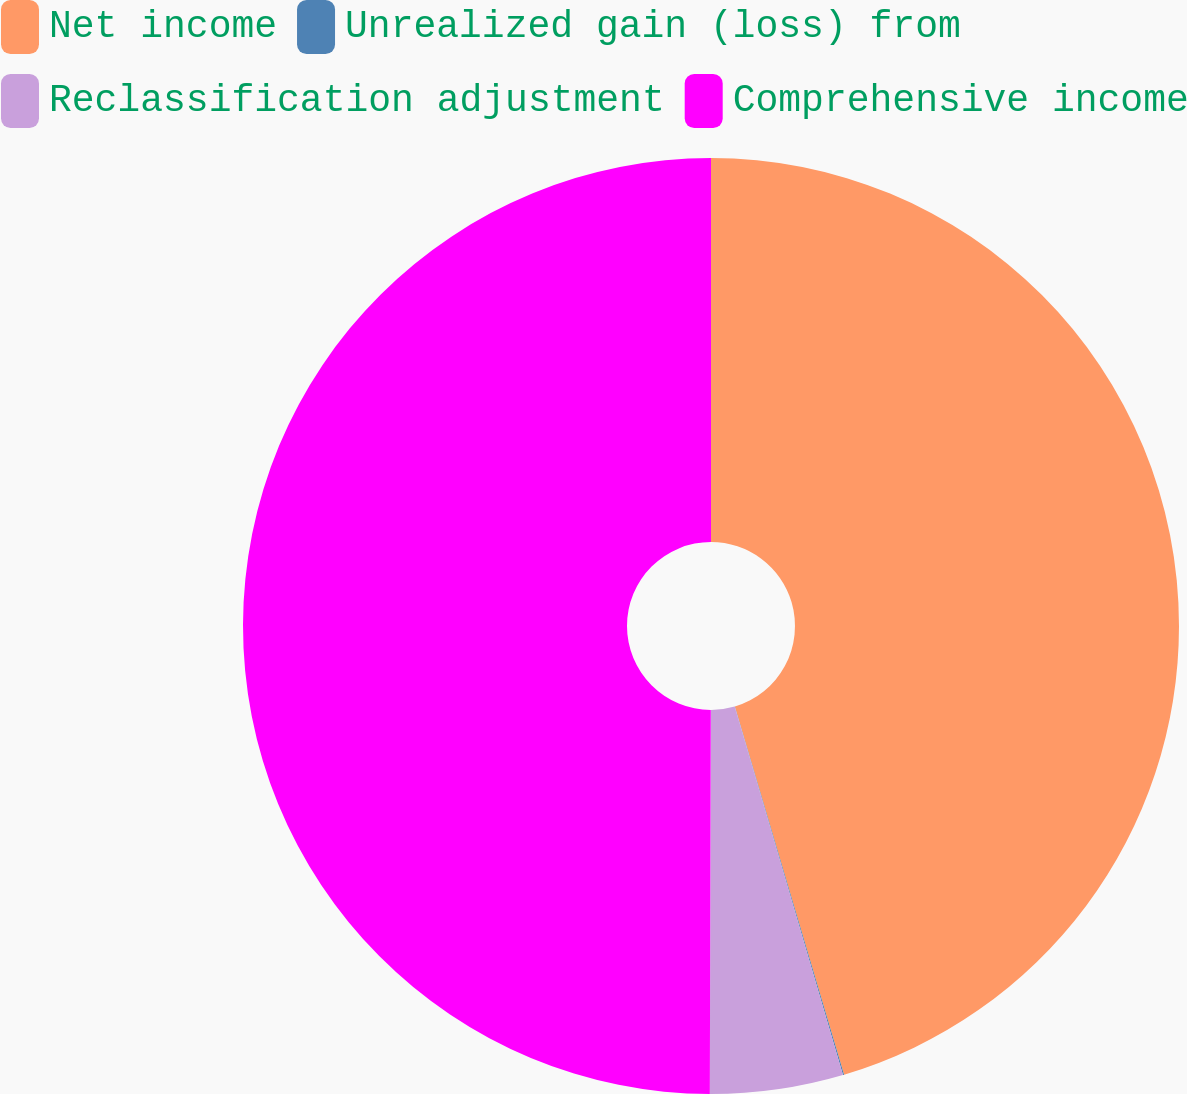Convert chart. <chart><loc_0><loc_0><loc_500><loc_500><pie_chart><fcel>Net income<fcel>Unrealized gain (loss) from<fcel>Reclassification adjustment<fcel>Comprehensive income<nl><fcel>45.41%<fcel>0.04%<fcel>4.59%<fcel>49.96%<nl></chart> 